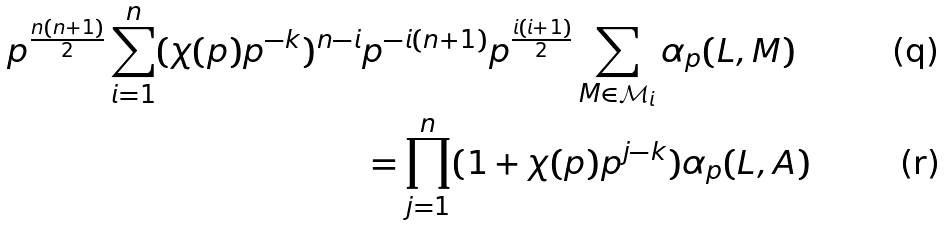Convert formula to latex. <formula><loc_0><loc_0><loc_500><loc_500>p ^ { \frac { n ( n + 1 ) } { 2 } } \sum _ { i = 1 } ^ { n } ( \chi ( p ) p ^ { - k } ) ^ { n - i } & p ^ { - i ( n + 1 ) } p ^ { \frac { i ( i + 1 ) } { 2 } } \sum _ { M \in { \mathcal { M } } _ { i } } \alpha _ { p } ( L , M ) \\ & = \prod _ { j = 1 } ^ { n } ( 1 + \chi ( p ) p ^ { j - k } ) \alpha _ { p } ( L , A )</formula> 